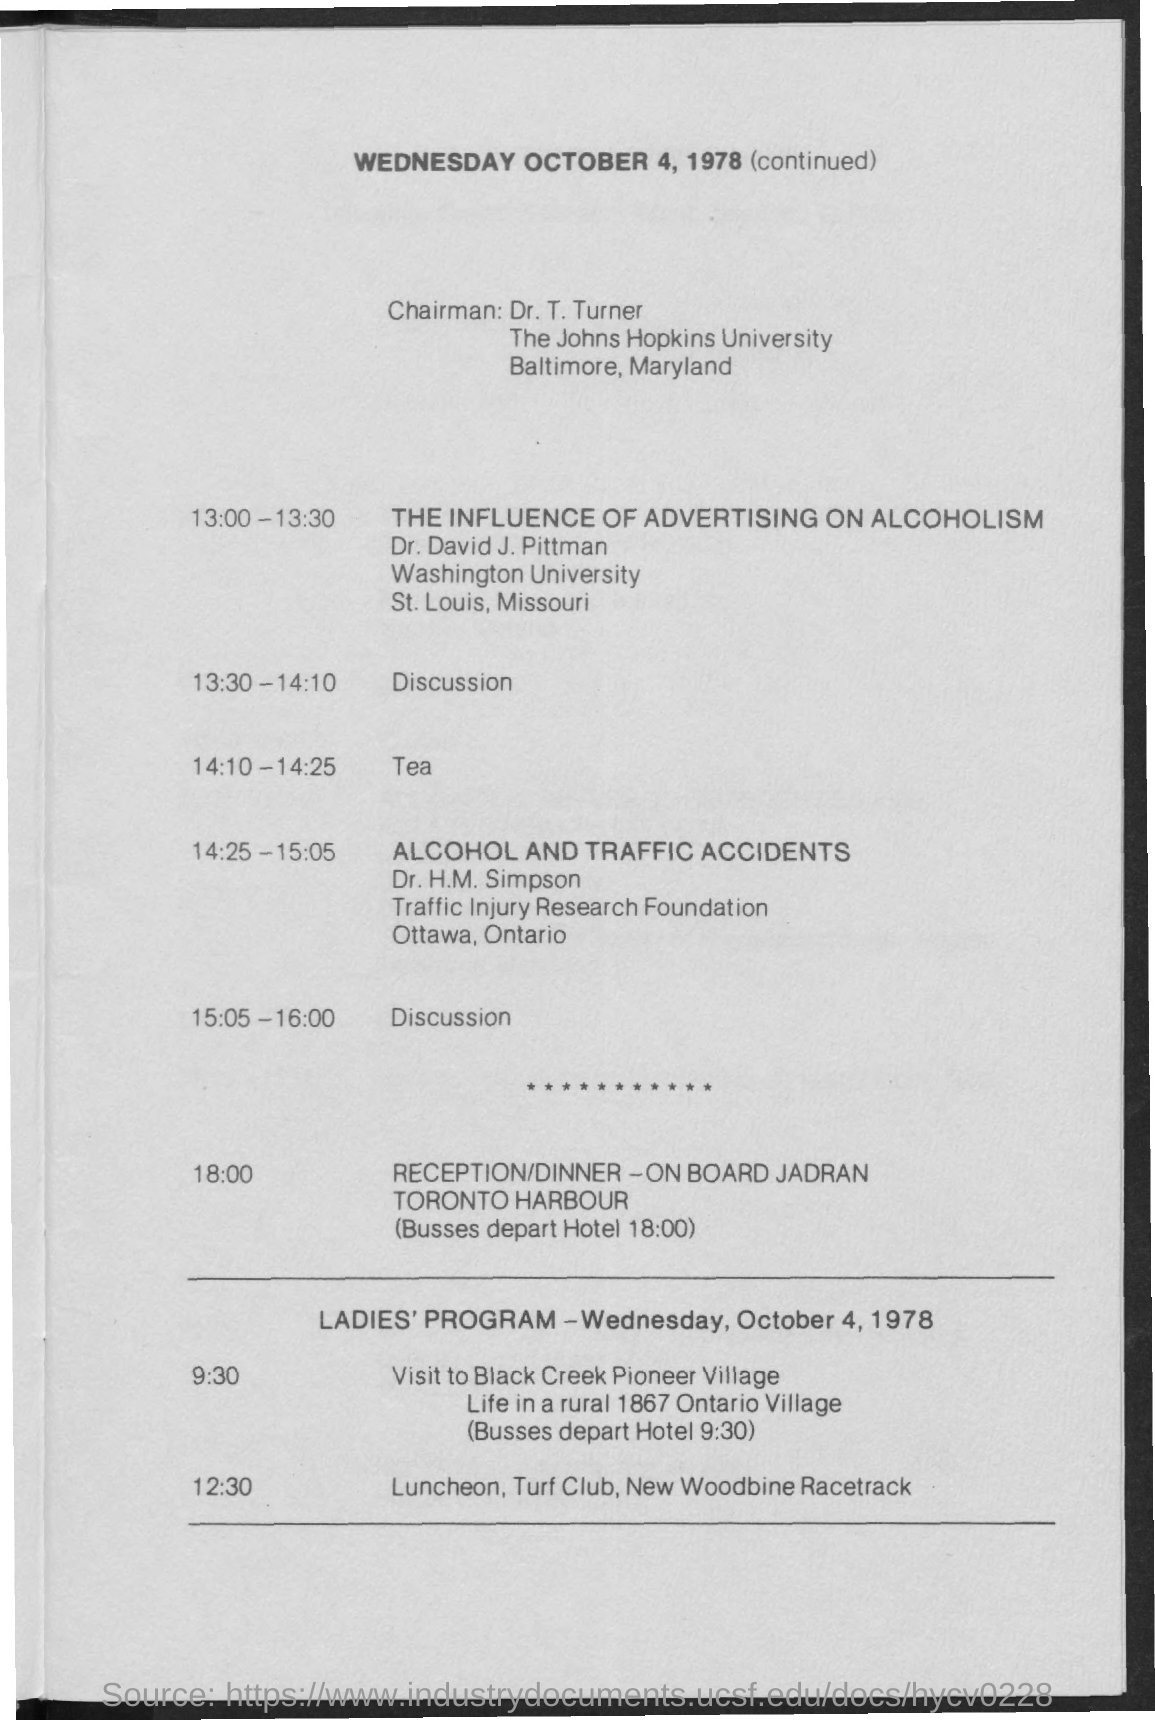Mention a couple of crucial points in this snapshot. The reception/dinner will take place at 6:00 PM. The reception/dinner is taking place at Toronto Harbour. The Chairman is Mr. Turner. 